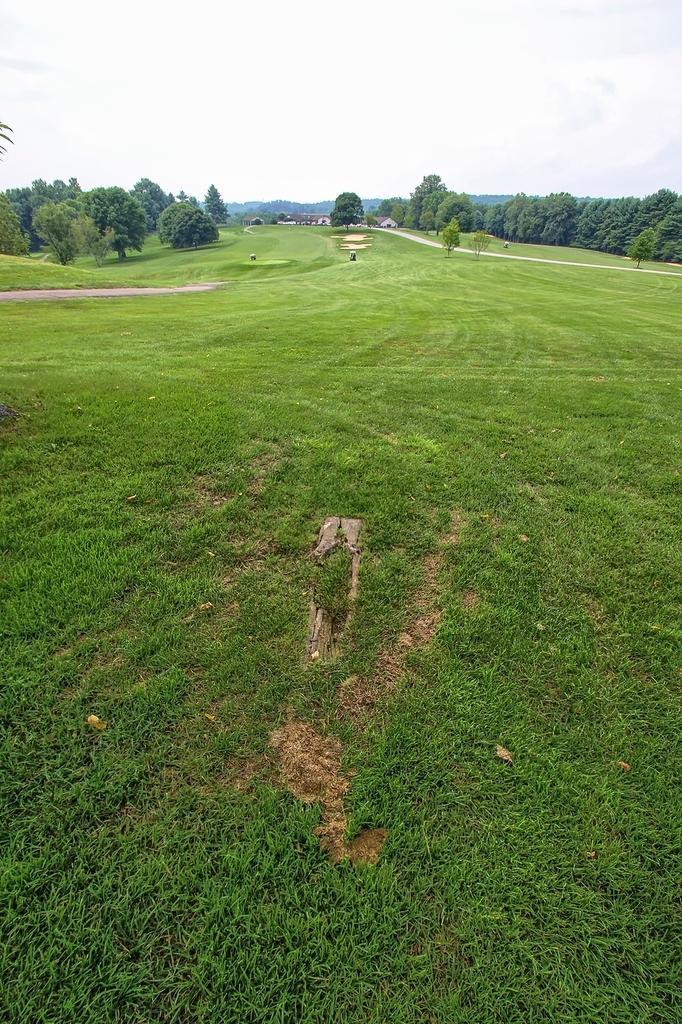Describe this image in one or two sentences. In this image there is a green field, on either side of the field there are trees, in the background there are houses and cloudy sky. 